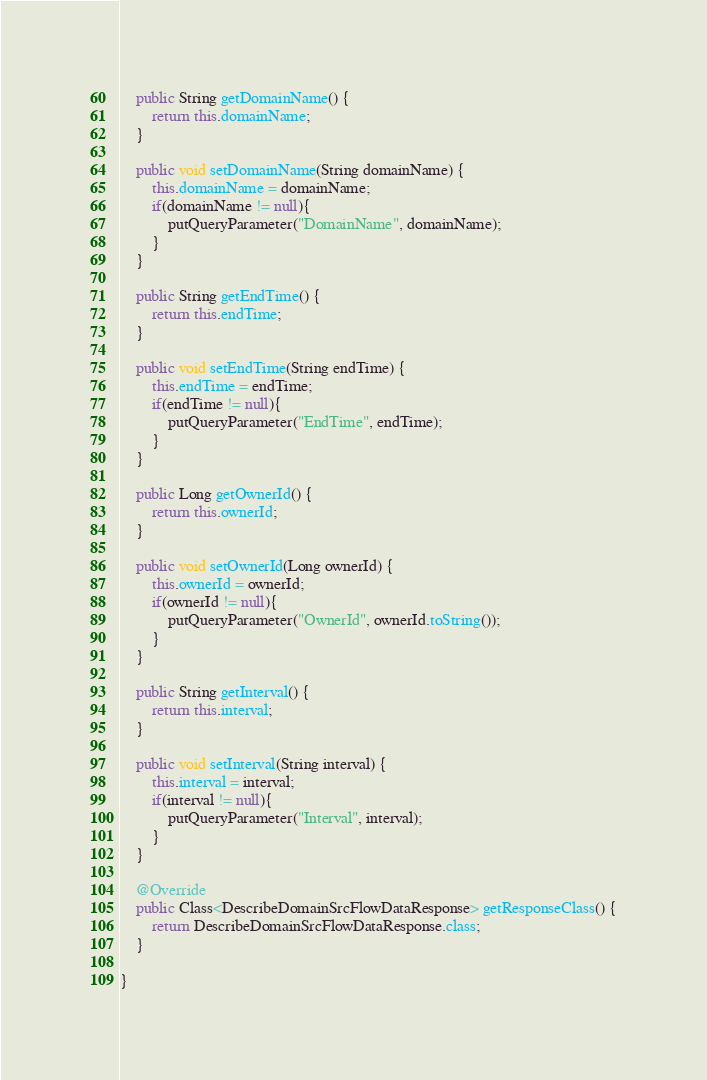Convert code to text. <code><loc_0><loc_0><loc_500><loc_500><_Java_>	public String getDomainName() {
		return this.domainName;
	}

	public void setDomainName(String domainName) {
		this.domainName = domainName;
		if(domainName != null){
			putQueryParameter("DomainName", domainName);
		}
	}

	public String getEndTime() {
		return this.endTime;
	}

	public void setEndTime(String endTime) {
		this.endTime = endTime;
		if(endTime != null){
			putQueryParameter("EndTime", endTime);
		}
	}

	public Long getOwnerId() {
		return this.ownerId;
	}

	public void setOwnerId(Long ownerId) {
		this.ownerId = ownerId;
		if(ownerId != null){
			putQueryParameter("OwnerId", ownerId.toString());
		}
	}

	public String getInterval() {
		return this.interval;
	}

	public void setInterval(String interval) {
		this.interval = interval;
		if(interval != null){
			putQueryParameter("Interval", interval);
		}
	}

	@Override
	public Class<DescribeDomainSrcFlowDataResponse> getResponseClass() {
		return DescribeDomainSrcFlowDataResponse.class;
	}

}
</code> 